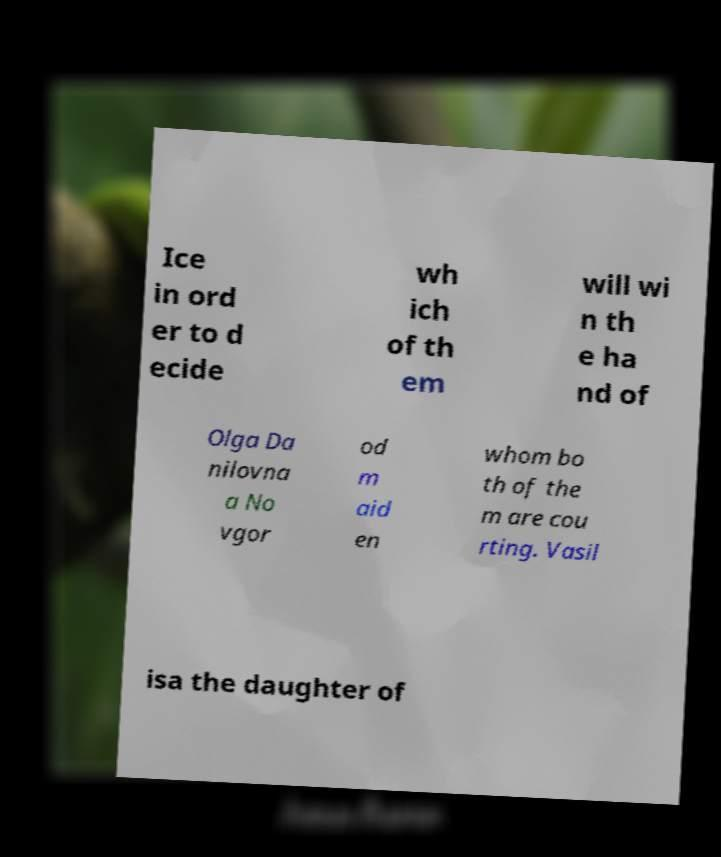I need the written content from this picture converted into text. Can you do that? Ice in ord er to d ecide wh ich of th em will wi n th e ha nd of Olga Da nilovna a No vgor od m aid en whom bo th of the m are cou rting. Vasil isa the daughter of 